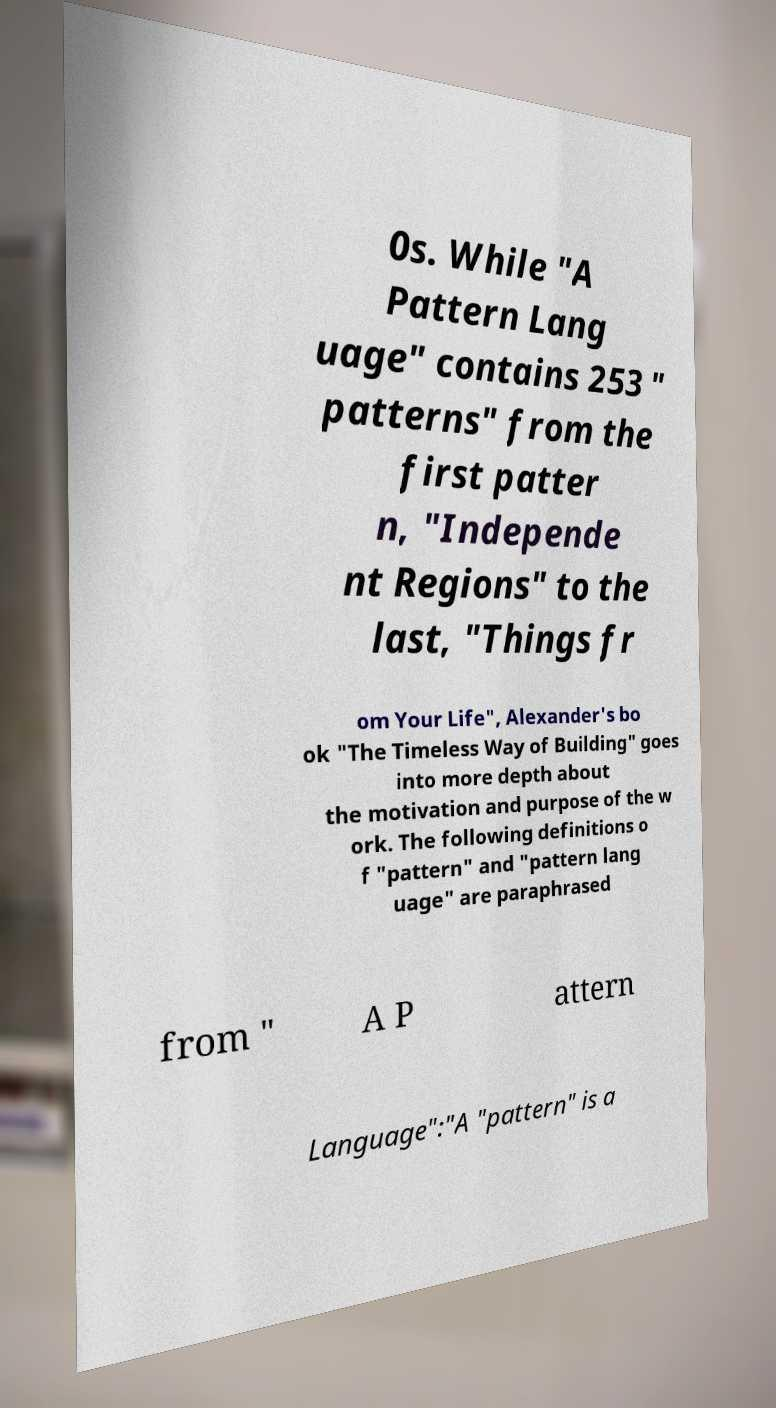Can you accurately transcribe the text from the provided image for me? 0s. While "A Pattern Lang uage" contains 253 " patterns" from the first patter n, "Independe nt Regions" to the last, "Things fr om Your Life", Alexander's bo ok "The Timeless Way of Building" goes into more depth about the motivation and purpose of the w ork. The following definitions o f "pattern" and "pattern lang uage" are paraphrased from " A P attern Language":"A "pattern" is a 